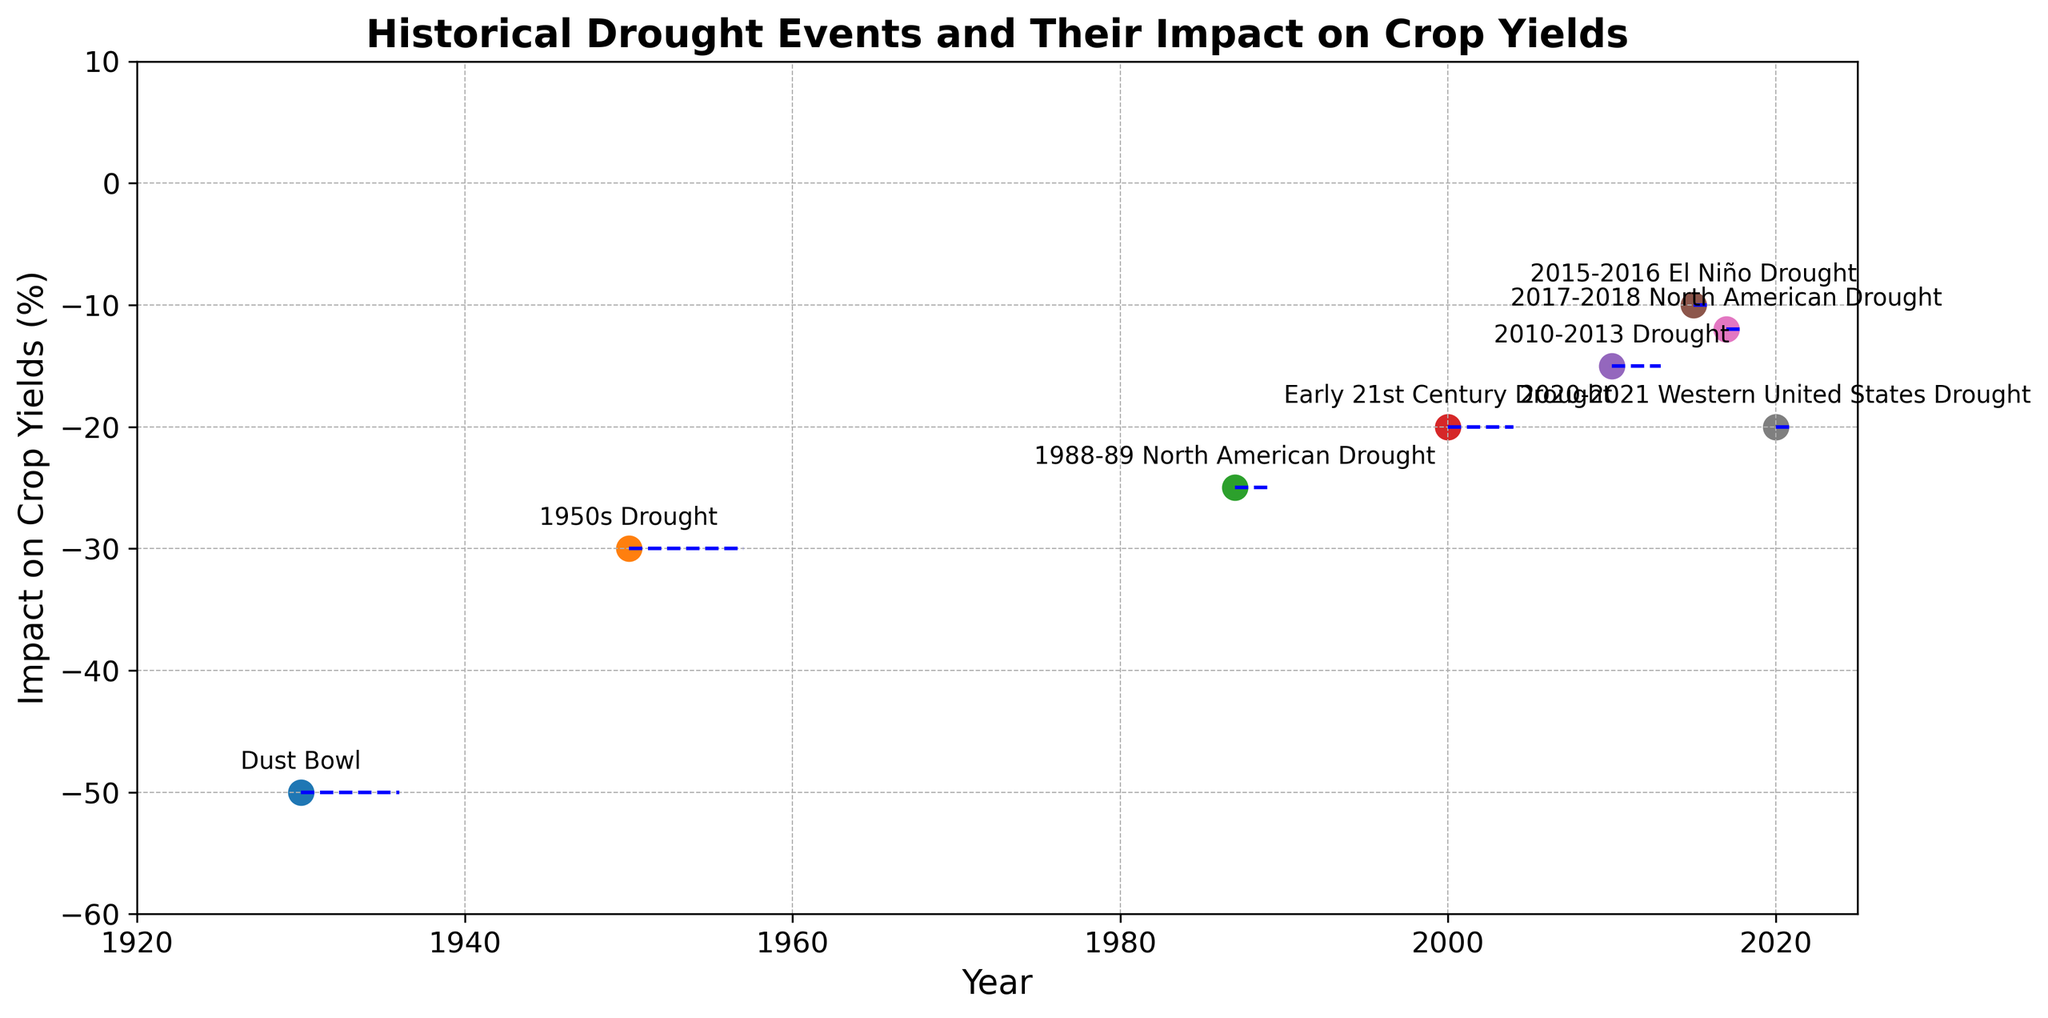Which drought event had the longest duration? The figure provides the duration of each drought event in months. The longest duration can be identified by finding the event with the largest duration marker. The "1950s Drought" had the longest duration of 84 months.
Answer: 1950s Drought What was the average impact on crop yields during the Dust Bowl and the 1950s Drought? To find the average impact, add the impacts of both events and divide by 2. The Dust Bowl's impact is -50%, and the 1950s Drought's impact is -30%. The average is (-50 + -30) / 2 = -40%.
Answer: -40% Which region was affected the most frequently by drought events in the past century? Count the number of drought events in each region listed in the figure. The "Western United States" appears most often in the visual, indicating it was affected most frequently by drought events with four occurrences.
Answer: Western United States Between the 2010-2013 Drought and the 2020-2021 Western United States Drought, which had a smaller negative impact on crop yields? Look at the markers for both events. The 2010-2013 Drought had an impact of -15%, whereas the 2020-2021 Drought had an impact of -20%. Therefore, the 2010-2013 Drought had a smaller negative impact on crop yields.
Answer: 2010-2013 Drought How does the duration of the Early 21st Century Drought compare with the 1988-89 North American Drought? The figure shows the duration in months for each drought. The Early 21st Century Drought lasted 48 months, and the 1988-89 North American Drought lasted 24 months. Hence, the Early 21st Century Drought was twice as long.
Answer: Twice as long What's the sum of the durations for the 2015-2016 El Niño Drought and the 2017-2018 North American Drought? Add the durations of both events. The 2015-2016 El Niño Drought lasted 12 months, and the 2017-2018 North American Drought lasted 18 months. Summing them gives 12 + 18 = 30 months.
Answer: 30 months Which event had the least impact on crop yields, and what was its duration? Scan the figure for the event with the highest percentage (least negative). The "2015-2016 El Niño Drought" had the least impact on crop yields at -10%. Its duration was 12 months.
Answer: 2015-2016 El Niño Drought, 12 months Which two drought events occurred consecutively, and how many years passed between their starting years? Identify pairs of consecutive events by looking at the starting years. The 2010-2013 Drought started in 2010, and the 2015-2016 El Niño Drought started in 2015. The gap between their starting years is 5 years.
Answer: 2010-2013 Drought and 2015-2016 El Niño Drought, 5 years What is the difference in the impact on crop yields between the Dust Bowl and the 2020-2021 Western United States Drought? Find the impacts for each event and subtract them. The Dust Bowl had an impact of -50%, and the 2020-2021 Western United States Drought had an impact of -20%. The difference is -50% - (-20%) = -30%.
Answer: -30% Comparing the Dust Bowl and the Early 21st Century Drought, which event lasted longer, and by how many months? Examine the duration of both droughts. The Dust Bowl lasted 72 months, and the Early 21st Century Drought lasted 48 months. The difference in their durations is 72 - 48 = 24 months.
Answer: Dust Bowl, 24 months 